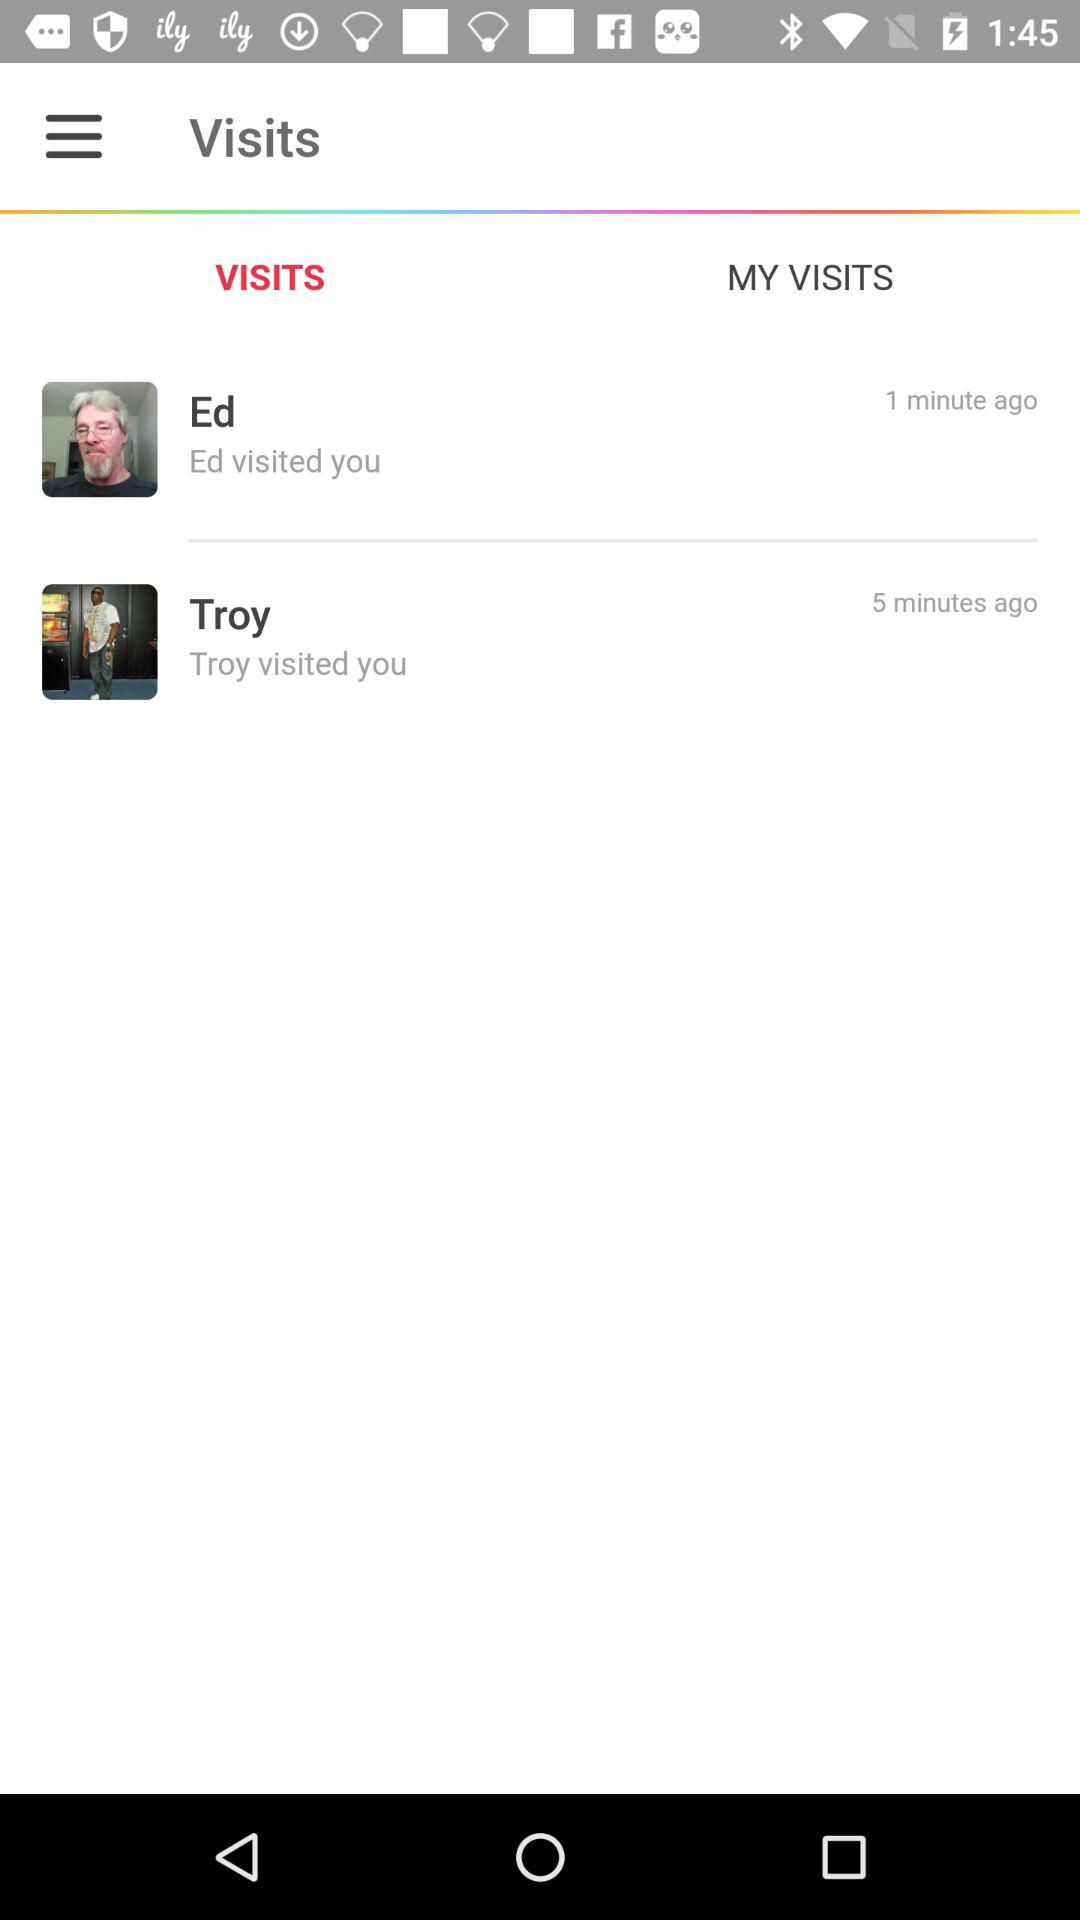How many more minutes ago did Ed visit than Troy?
Answer the question using a single word or phrase. 4 